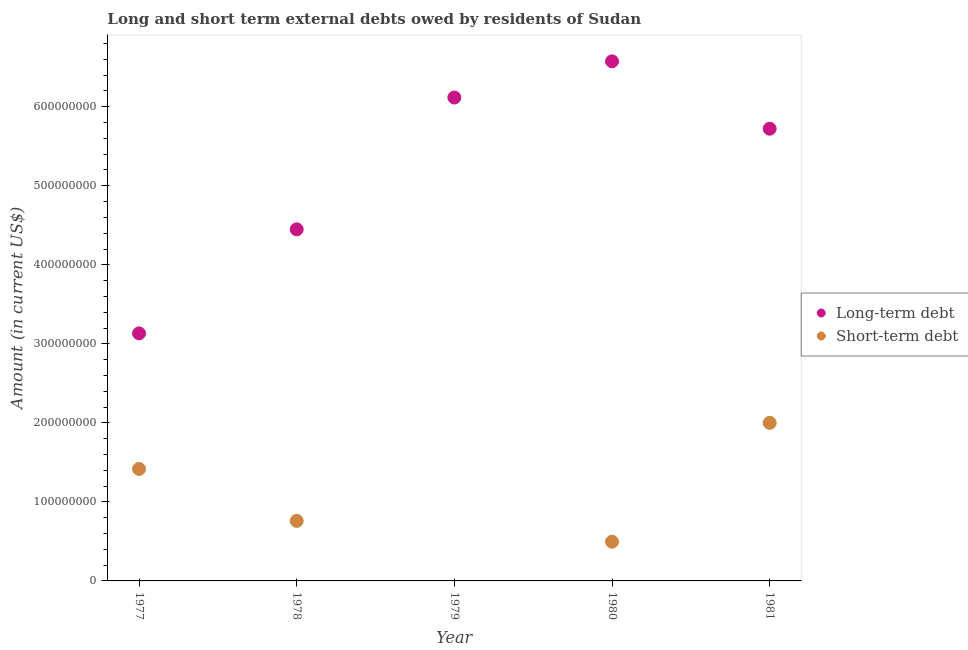How many different coloured dotlines are there?
Your answer should be compact. 2. Is the number of dotlines equal to the number of legend labels?
Offer a terse response. No. What is the short-term debts owed by residents in 1978?
Your answer should be very brief. 7.60e+07. Across all years, what is the maximum short-term debts owed by residents?
Provide a succinct answer. 2.00e+08. Across all years, what is the minimum short-term debts owed by residents?
Provide a short and direct response. 0. What is the total long-term debts owed by residents in the graph?
Provide a succinct answer. 2.60e+09. What is the difference between the short-term debts owed by residents in 1977 and that in 1978?
Your answer should be very brief. 6.57e+07. What is the difference between the long-term debts owed by residents in 1979 and the short-term debts owed by residents in 1977?
Offer a very short reply. 4.70e+08. What is the average short-term debts owed by residents per year?
Your answer should be very brief. 9.35e+07. In the year 1977, what is the difference between the short-term debts owed by residents and long-term debts owed by residents?
Keep it short and to the point. -1.72e+08. What is the ratio of the long-term debts owed by residents in 1980 to that in 1981?
Provide a short and direct response. 1.15. What is the difference between the highest and the second highest long-term debts owed by residents?
Offer a terse response. 4.58e+07. What is the difference between the highest and the lowest short-term debts owed by residents?
Your answer should be compact. 2.00e+08. In how many years, is the short-term debts owed by residents greater than the average short-term debts owed by residents taken over all years?
Your response must be concise. 2. Does the long-term debts owed by residents monotonically increase over the years?
Offer a very short reply. No. Is the long-term debts owed by residents strictly less than the short-term debts owed by residents over the years?
Offer a very short reply. No. How many years are there in the graph?
Ensure brevity in your answer.  5. What is the difference between two consecutive major ticks on the Y-axis?
Your answer should be very brief. 1.00e+08. Where does the legend appear in the graph?
Offer a very short reply. Center right. How many legend labels are there?
Your answer should be compact. 2. How are the legend labels stacked?
Make the answer very short. Vertical. What is the title of the graph?
Give a very brief answer. Long and short term external debts owed by residents of Sudan. What is the Amount (in current US$) in Long-term debt in 1977?
Provide a succinct answer. 3.13e+08. What is the Amount (in current US$) in Short-term debt in 1977?
Your answer should be very brief. 1.42e+08. What is the Amount (in current US$) in Long-term debt in 1978?
Offer a very short reply. 4.45e+08. What is the Amount (in current US$) of Short-term debt in 1978?
Offer a very short reply. 7.60e+07. What is the Amount (in current US$) of Long-term debt in 1979?
Ensure brevity in your answer.  6.12e+08. What is the Amount (in current US$) in Long-term debt in 1980?
Give a very brief answer. 6.57e+08. What is the Amount (in current US$) of Short-term debt in 1980?
Offer a terse response. 4.96e+07. What is the Amount (in current US$) of Long-term debt in 1981?
Your answer should be compact. 5.72e+08. Across all years, what is the maximum Amount (in current US$) in Long-term debt?
Keep it short and to the point. 6.57e+08. Across all years, what is the minimum Amount (in current US$) of Long-term debt?
Give a very brief answer. 3.13e+08. Across all years, what is the minimum Amount (in current US$) in Short-term debt?
Provide a short and direct response. 0. What is the total Amount (in current US$) of Long-term debt in the graph?
Ensure brevity in your answer.  2.60e+09. What is the total Amount (in current US$) of Short-term debt in the graph?
Provide a short and direct response. 4.67e+08. What is the difference between the Amount (in current US$) of Long-term debt in 1977 and that in 1978?
Offer a terse response. -1.32e+08. What is the difference between the Amount (in current US$) of Short-term debt in 1977 and that in 1978?
Your answer should be compact. 6.57e+07. What is the difference between the Amount (in current US$) in Long-term debt in 1977 and that in 1979?
Make the answer very short. -2.98e+08. What is the difference between the Amount (in current US$) in Long-term debt in 1977 and that in 1980?
Make the answer very short. -3.44e+08. What is the difference between the Amount (in current US$) in Short-term debt in 1977 and that in 1980?
Give a very brief answer. 9.21e+07. What is the difference between the Amount (in current US$) of Long-term debt in 1977 and that in 1981?
Offer a terse response. -2.59e+08. What is the difference between the Amount (in current US$) in Short-term debt in 1977 and that in 1981?
Ensure brevity in your answer.  -5.83e+07. What is the difference between the Amount (in current US$) in Long-term debt in 1978 and that in 1979?
Offer a terse response. -1.67e+08. What is the difference between the Amount (in current US$) of Long-term debt in 1978 and that in 1980?
Give a very brief answer. -2.13e+08. What is the difference between the Amount (in current US$) in Short-term debt in 1978 and that in 1980?
Provide a short and direct response. 2.64e+07. What is the difference between the Amount (in current US$) of Long-term debt in 1978 and that in 1981?
Your answer should be compact. -1.27e+08. What is the difference between the Amount (in current US$) of Short-term debt in 1978 and that in 1981?
Ensure brevity in your answer.  -1.24e+08. What is the difference between the Amount (in current US$) of Long-term debt in 1979 and that in 1980?
Give a very brief answer. -4.58e+07. What is the difference between the Amount (in current US$) in Long-term debt in 1979 and that in 1981?
Give a very brief answer. 3.94e+07. What is the difference between the Amount (in current US$) in Long-term debt in 1980 and that in 1981?
Offer a terse response. 8.52e+07. What is the difference between the Amount (in current US$) in Short-term debt in 1980 and that in 1981?
Keep it short and to the point. -1.50e+08. What is the difference between the Amount (in current US$) in Long-term debt in 1977 and the Amount (in current US$) in Short-term debt in 1978?
Make the answer very short. 2.37e+08. What is the difference between the Amount (in current US$) of Long-term debt in 1977 and the Amount (in current US$) of Short-term debt in 1980?
Your answer should be compact. 2.64e+08. What is the difference between the Amount (in current US$) in Long-term debt in 1977 and the Amount (in current US$) in Short-term debt in 1981?
Make the answer very short. 1.13e+08. What is the difference between the Amount (in current US$) of Long-term debt in 1978 and the Amount (in current US$) of Short-term debt in 1980?
Your answer should be very brief. 3.95e+08. What is the difference between the Amount (in current US$) in Long-term debt in 1978 and the Amount (in current US$) in Short-term debt in 1981?
Offer a very short reply. 2.45e+08. What is the difference between the Amount (in current US$) in Long-term debt in 1979 and the Amount (in current US$) in Short-term debt in 1980?
Your answer should be very brief. 5.62e+08. What is the difference between the Amount (in current US$) of Long-term debt in 1979 and the Amount (in current US$) of Short-term debt in 1981?
Your answer should be very brief. 4.12e+08. What is the difference between the Amount (in current US$) of Long-term debt in 1980 and the Amount (in current US$) of Short-term debt in 1981?
Provide a succinct answer. 4.57e+08. What is the average Amount (in current US$) of Long-term debt per year?
Give a very brief answer. 5.20e+08. What is the average Amount (in current US$) of Short-term debt per year?
Ensure brevity in your answer.  9.35e+07. In the year 1977, what is the difference between the Amount (in current US$) in Long-term debt and Amount (in current US$) in Short-term debt?
Your answer should be very brief. 1.72e+08. In the year 1978, what is the difference between the Amount (in current US$) of Long-term debt and Amount (in current US$) of Short-term debt?
Ensure brevity in your answer.  3.69e+08. In the year 1980, what is the difference between the Amount (in current US$) in Long-term debt and Amount (in current US$) in Short-term debt?
Provide a succinct answer. 6.08e+08. In the year 1981, what is the difference between the Amount (in current US$) in Long-term debt and Amount (in current US$) in Short-term debt?
Offer a terse response. 3.72e+08. What is the ratio of the Amount (in current US$) of Long-term debt in 1977 to that in 1978?
Your answer should be compact. 0.7. What is the ratio of the Amount (in current US$) in Short-term debt in 1977 to that in 1978?
Your response must be concise. 1.86. What is the ratio of the Amount (in current US$) of Long-term debt in 1977 to that in 1979?
Keep it short and to the point. 0.51. What is the ratio of the Amount (in current US$) in Long-term debt in 1977 to that in 1980?
Your answer should be compact. 0.48. What is the ratio of the Amount (in current US$) of Short-term debt in 1977 to that in 1980?
Your response must be concise. 2.86. What is the ratio of the Amount (in current US$) of Long-term debt in 1977 to that in 1981?
Ensure brevity in your answer.  0.55. What is the ratio of the Amount (in current US$) of Short-term debt in 1977 to that in 1981?
Ensure brevity in your answer.  0.71. What is the ratio of the Amount (in current US$) of Long-term debt in 1978 to that in 1979?
Provide a succinct answer. 0.73. What is the ratio of the Amount (in current US$) of Long-term debt in 1978 to that in 1980?
Your answer should be compact. 0.68. What is the ratio of the Amount (in current US$) of Short-term debt in 1978 to that in 1980?
Offer a terse response. 1.53. What is the ratio of the Amount (in current US$) of Long-term debt in 1978 to that in 1981?
Your answer should be very brief. 0.78. What is the ratio of the Amount (in current US$) of Short-term debt in 1978 to that in 1981?
Provide a short and direct response. 0.38. What is the ratio of the Amount (in current US$) of Long-term debt in 1979 to that in 1980?
Provide a succinct answer. 0.93. What is the ratio of the Amount (in current US$) in Long-term debt in 1979 to that in 1981?
Make the answer very short. 1.07. What is the ratio of the Amount (in current US$) in Long-term debt in 1980 to that in 1981?
Your answer should be compact. 1.15. What is the ratio of the Amount (in current US$) of Short-term debt in 1980 to that in 1981?
Your response must be concise. 0.25. What is the difference between the highest and the second highest Amount (in current US$) of Long-term debt?
Keep it short and to the point. 4.58e+07. What is the difference between the highest and the second highest Amount (in current US$) in Short-term debt?
Keep it short and to the point. 5.83e+07. What is the difference between the highest and the lowest Amount (in current US$) of Long-term debt?
Make the answer very short. 3.44e+08. What is the difference between the highest and the lowest Amount (in current US$) of Short-term debt?
Provide a short and direct response. 2.00e+08. 